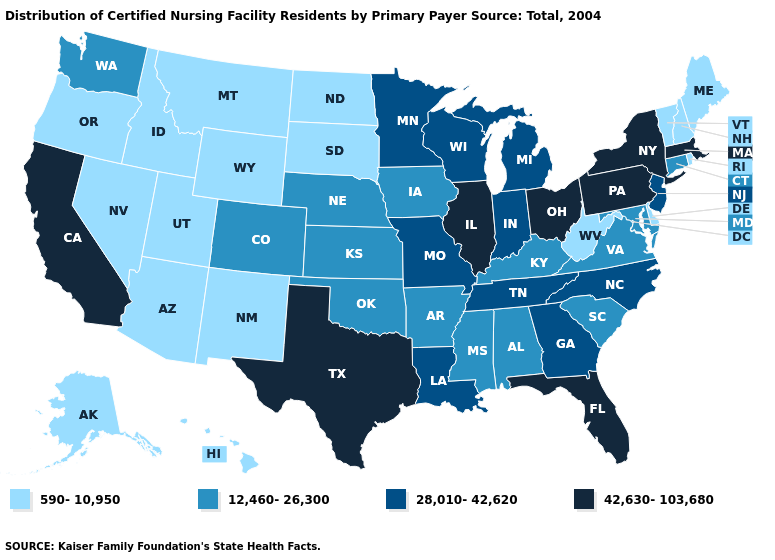Does West Virginia have the highest value in the South?
Give a very brief answer. No. Name the states that have a value in the range 42,630-103,680?
Give a very brief answer. California, Florida, Illinois, Massachusetts, New York, Ohio, Pennsylvania, Texas. What is the value of Maine?
Short answer required. 590-10,950. How many symbols are there in the legend?
Answer briefly. 4. Among the states that border West Virginia , does Kentucky have the highest value?
Be succinct. No. Is the legend a continuous bar?
Give a very brief answer. No. Name the states that have a value in the range 590-10,950?
Write a very short answer. Alaska, Arizona, Delaware, Hawaii, Idaho, Maine, Montana, Nevada, New Hampshire, New Mexico, North Dakota, Oregon, Rhode Island, South Dakota, Utah, Vermont, West Virginia, Wyoming. Among the states that border Oklahoma , does Texas have the highest value?
Be succinct. Yes. What is the value of New Jersey?
Keep it brief. 28,010-42,620. Does Maine have the same value as Kansas?
Answer briefly. No. Among the states that border Illinois , does Iowa have the highest value?
Short answer required. No. Name the states that have a value in the range 28,010-42,620?
Concise answer only. Georgia, Indiana, Louisiana, Michigan, Minnesota, Missouri, New Jersey, North Carolina, Tennessee, Wisconsin. Does Idaho have a higher value than Alaska?
Quick response, please. No. Name the states that have a value in the range 12,460-26,300?
Keep it brief. Alabama, Arkansas, Colorado, Connecticut, Iowa, Kansas, Kentucky, Maryland, Mississippi, Nebraska, Oklahoma, South Carolina, Virginia, Washington. Which states have the lowest value in the MidWest?
Write a very short answer. North Dakota, South Dakota. 